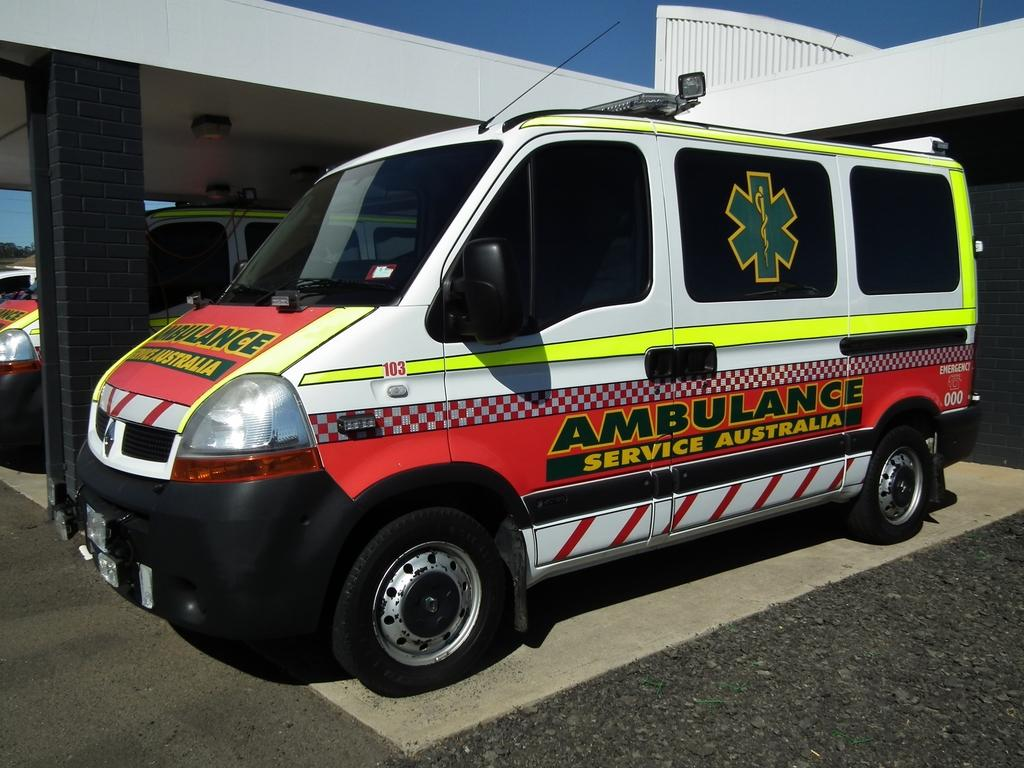Provide a one-sentence caption for the provided image. An Ambulance that says Ambulance Service Australia down the side of it. 